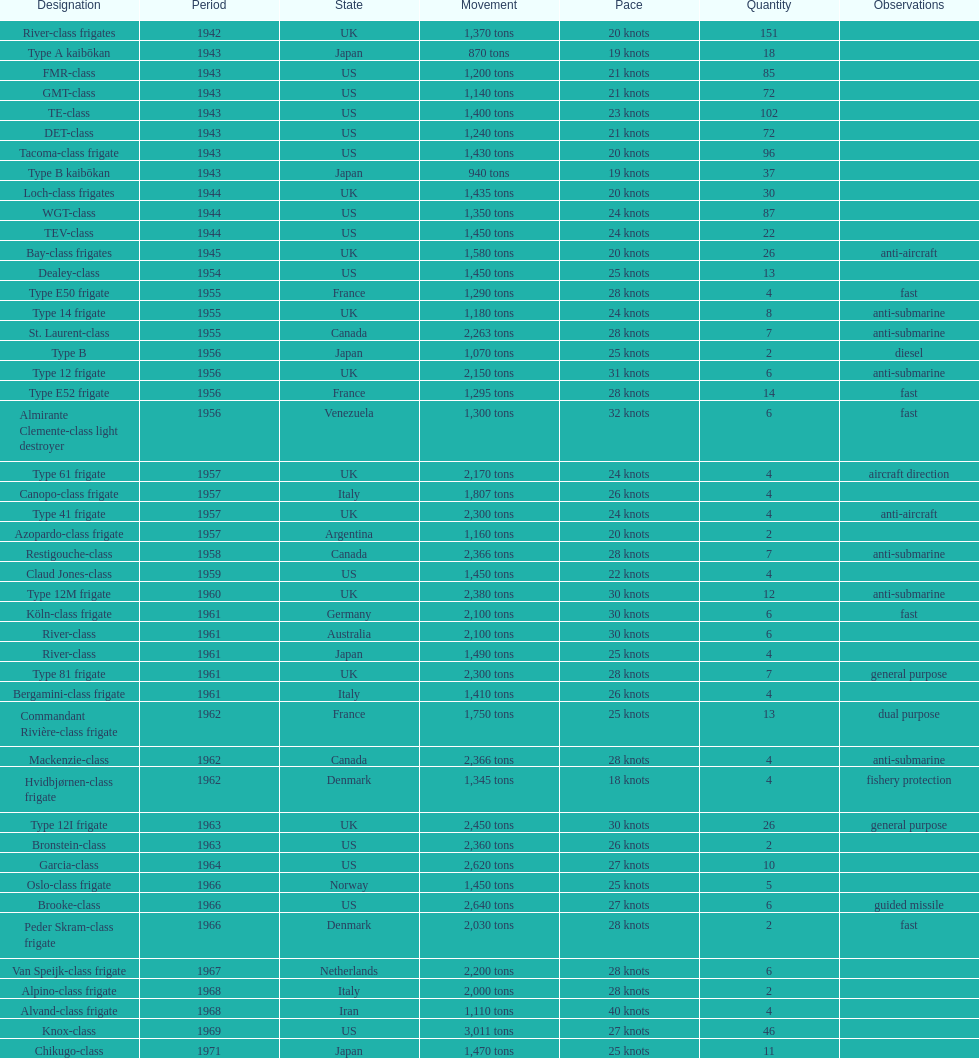Which of the boats listed is the fastest? Alvand-class frigate. 